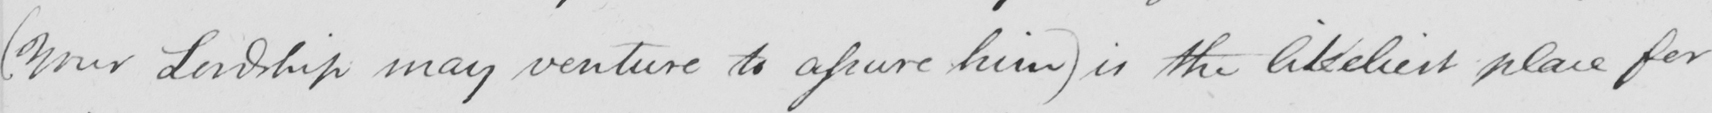Transcribe the text shown in this historical manuscript line. ( Your Lordship may venture to assure him )  is the likeliest place for 